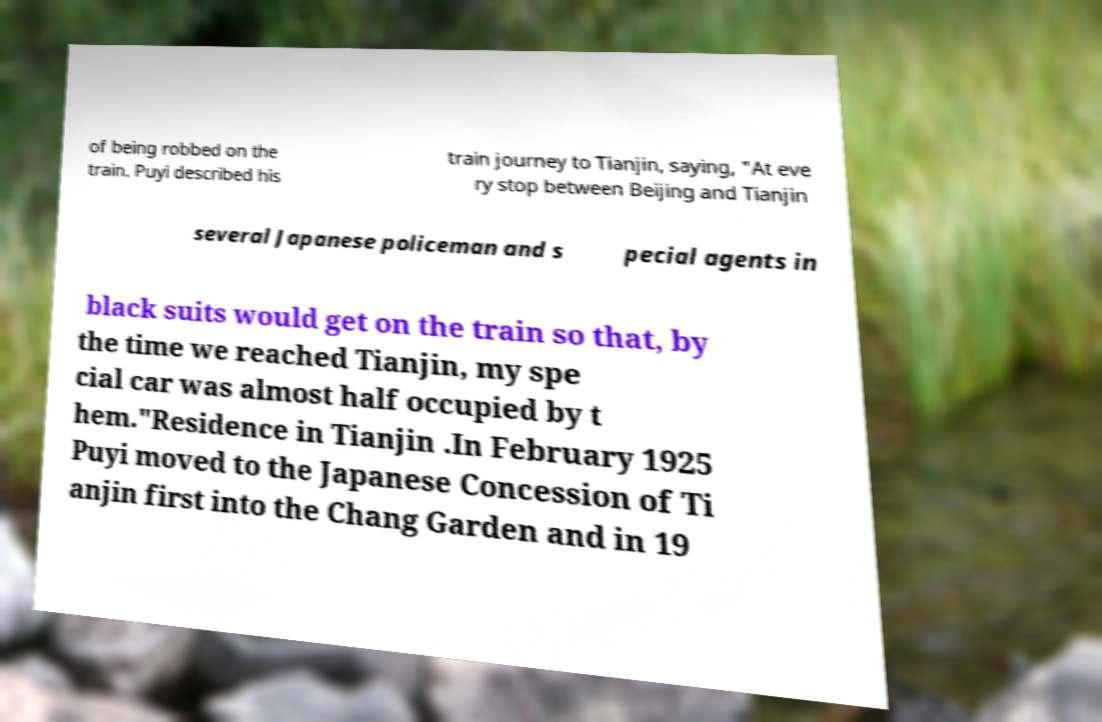I need the written content from this picture converted into text. Can you do that? of being robbed on the train. Puyi described his train journey to Tianjin, saying, "At eve ry stop between Beijing and Tianjin several Japanese policeman and s pecial agents in black suits would get on the train so that, by the time we reached Tianjin, my spe cial car was almost half occupied by t hem."Residence in Tianjin .In February 1925 Puyi moved to the Japanese Concession of Ti anjin first into the Chang Garden and in 19 